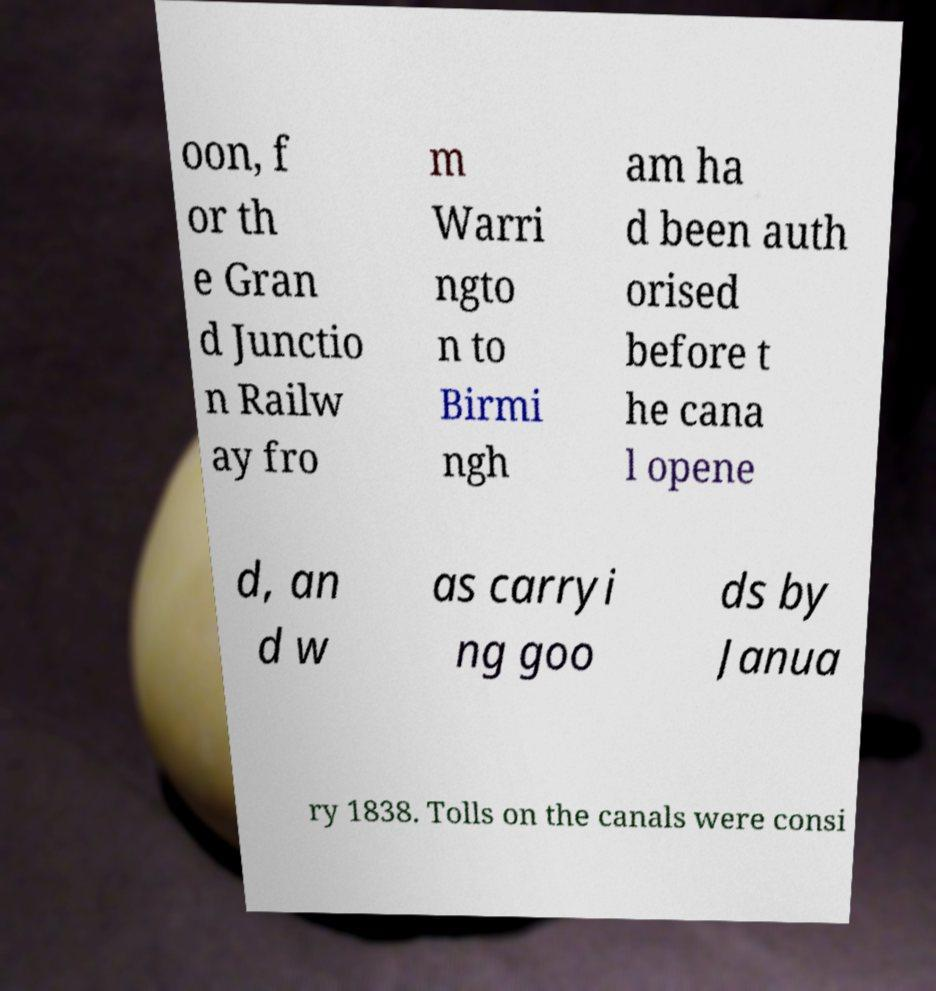Please identify and transcribe the text found in this image. oon, f or th e Gran d Junctio n Railw ay fro m Warri ngto n to Birmi ngh am ha d been auth orised before t he cana l opene d, an d w as carryi ng goo ds by Janua ry 1838. Tolls on the canals were consi 